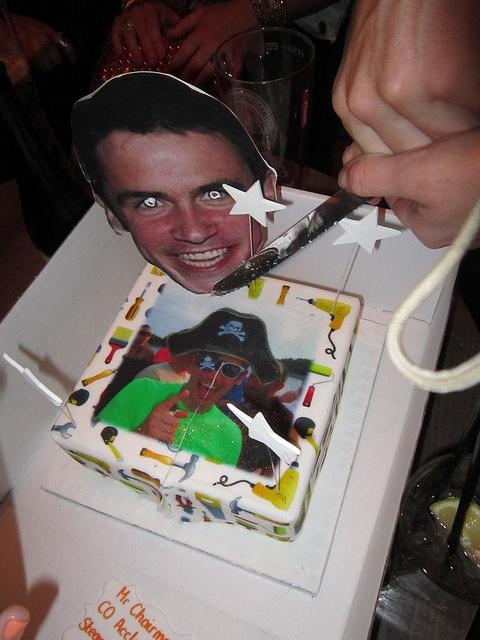What is in the person's hands?
Be succinct. Knife. Is the man happy?
Keep it brief. Yes. What famous cartoon character is on this cake?
Write a very short answer. None. Is the guy smiling?
Give a very brief answer. Yes. What shape is the cake?
Quick response, please. Square. Are the lights on?
Short answer required. Yes. 